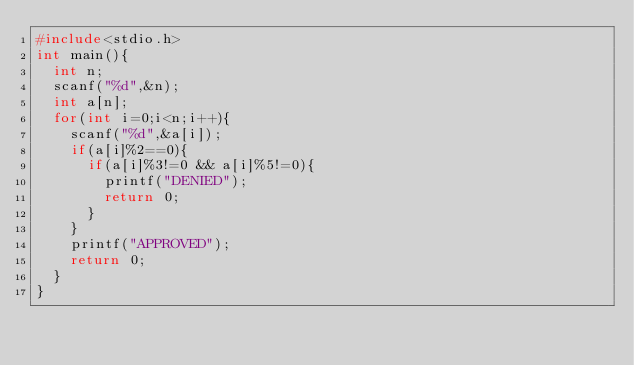Convert code to text. <code><loc_0><loc_0><loc_500><loc_500><_C_>#include<stdio.h>
int main(){
  int n;
  scanf("%d",&n);
  int a[n];
  for(int i=0;i<n;i++){
    scanf("%d",&a[i]);
    if(a[i]%2==0){
      if(a[i]%3!=0 && a[i]%5!=0){
        printf("DENIED");
        return 0;
      }
    }
    printf("APPROVED");
    return 0;
  }
}
  
</code> 